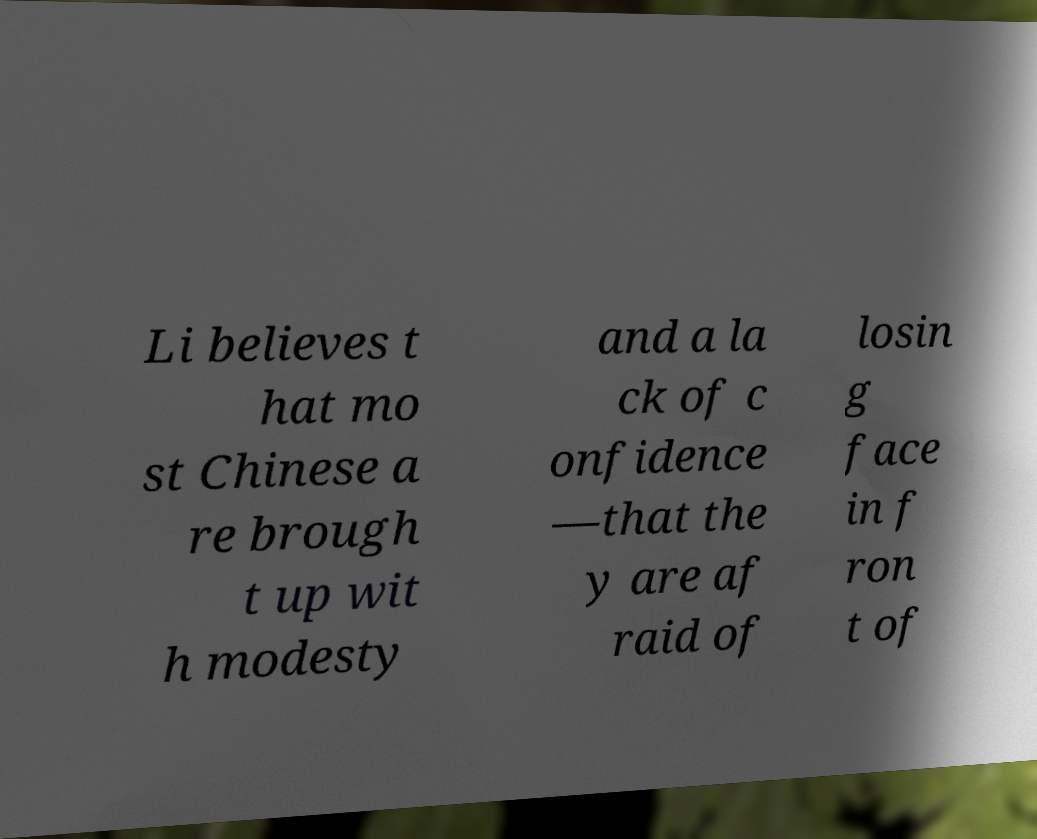There's text embedded in this image that I need extracted. Can you transcribe it verbatim? Li believes t hat mo st Chinese a re brough t up wit h modesty and a la ck of c onfidence —that the y are af raid of losin g face in f ron t of 